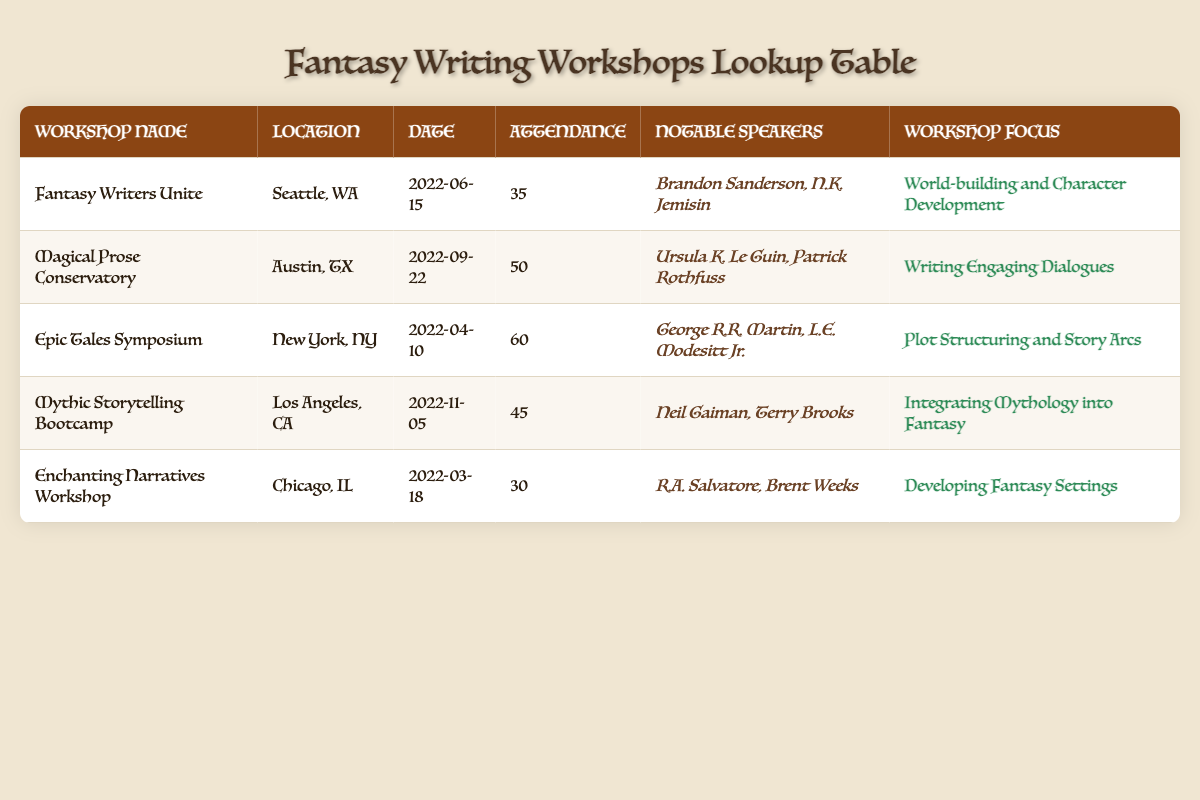What was the attendance at the "Epic Tales Symposium"? The table provides a specific entry for the "Epic Tales Symposium," which shows that the attendance was 60.
Answer: 60 Which workshop focused on "Integrating Mythology into Fantasy"? By looking at the workshop focus in the table, "Mythic Storytelling Bootcamp" is listed under that category, indicating it's the workshop that focused on integrating mythology.
Answer: Mythic Storytelling Bootcamp How many workshops had an attendance of 45 or more? We need to count the workshops with attendance values of 45 or higher. The workshops with attendance of 60, 50, 45, and 35 are: "Epic Tales Symposium," "Magical Prose Conservatory," and "Mythic Storytelling Bootcamp." This totals three workshops.
Answer: 3 What is the average attendance across all workshops? First, we need to sum the attendance: 35 + 50 + 60 + 45 + 30 = 220. Then, we divide by the number of workshops (5): 220 / 5 = 44.
Answer: 44 Did any workshop feature George R.R. Martin as a speaker? The table lists George R.R. Martin under notable speakers for the "Epic Tales Symposium," confirming that he did participate in a workshop.
Answer: Yes Which workshop had the lowest attendance and what was that number? Checking the attendance numbers across all entries, the workshop with the lowest attendance is "Enchanting Narratives Workshop" with an attendance of 30.
Answer: 30 How many workshops were held in California? Looking at the location column, we see that only "Mythic Storytelling Bootcamp" is located in Los Angeles, CA. This shows there was only one workshop held in California.
Answer: 1 Which notable speakers were present at the "Magical Prose Conservatory"? The table clearly lists "Ursula K. Le Guin" and "Patrick Rothfuss" as the notable speakers for the "Magical Prose Conservatory."
Answer: Ursula K. Le Guin, Patrick Rothfuss Was there a workshop in Seattle, WA? The table shows that "Fantasy Writers Unite" was located in Seattle, WA, confirming the existence of a workshop in that city.
Answer: Yes 